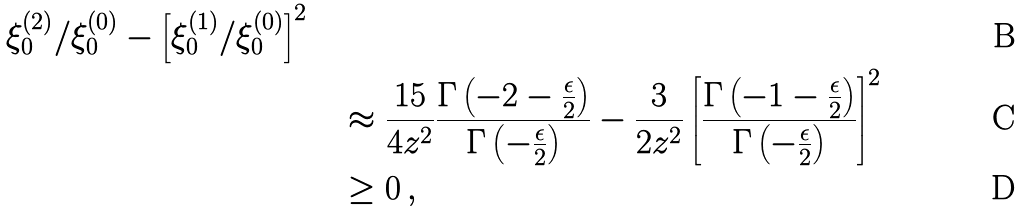Convert formula to latex. <formula><loc_0><loc_0><loc_500><loc_500>{ \xi _ { 0 } ^ { ( 2 ) } / \xi _ { 0 } ^ { ( 0 ) } - \left [ \xi _ { 0 } ^ { ( 1 ) } / \xi _ { 0 } ^ { ( 0 ) } \right ] ^ { 2 } } \\ & \quad \approx \frac { 1 5 } { 4 z ^ { 2 } } \frac { \Gamma \left ( - 2 - \frac { \epsilon } { 2 } \right ) } { \Gamma \left ( - \frac { \epsilon } { 2 } \right ) } - \frac { 3 } { 2 z ^ { 2 } } \left [ \frac { \Gamma \left ( - 1 - \frac { \epsilon } { 2 } \right ) } { \Gamma \left ( - \frac { \epsilon } { 2 } \right ) } \right ] ^ { 2 } \\ & \quad \geq 0 \, ,</formula> 